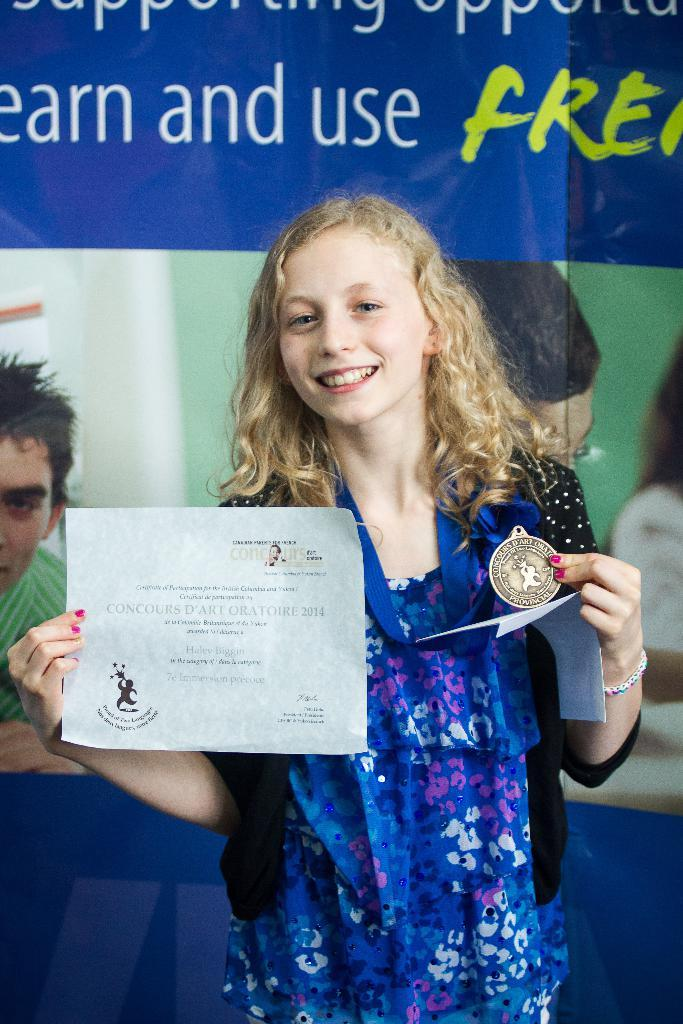What is present in the image? There is a person in the image. Can you describe the person's attire? The person is wearing a dress with blue, black, and pink colors. What is the person holding in the image? The person is holding a medal and a certificate. What can be seen in the background of the image? There is a banner in the background of the image. How many frogs are sitting on the appliance in the image? There are no frogs or appliances present in the image. 